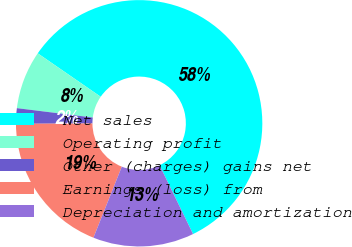Convert chart. <chart><loc_0><loc_0><loc_500><loc_500><pie_chart><fcel>Net sales<fcel>Operating profit<fcel>Other (charges) gains net<fcel>Earnings (loss) from<fcel>Depreciation and amortization<nl><fcel>58.18%<fcel>7.65%<fcel>2.03%<fcel>18.88%<fcel>13.26%<nl></chart> 